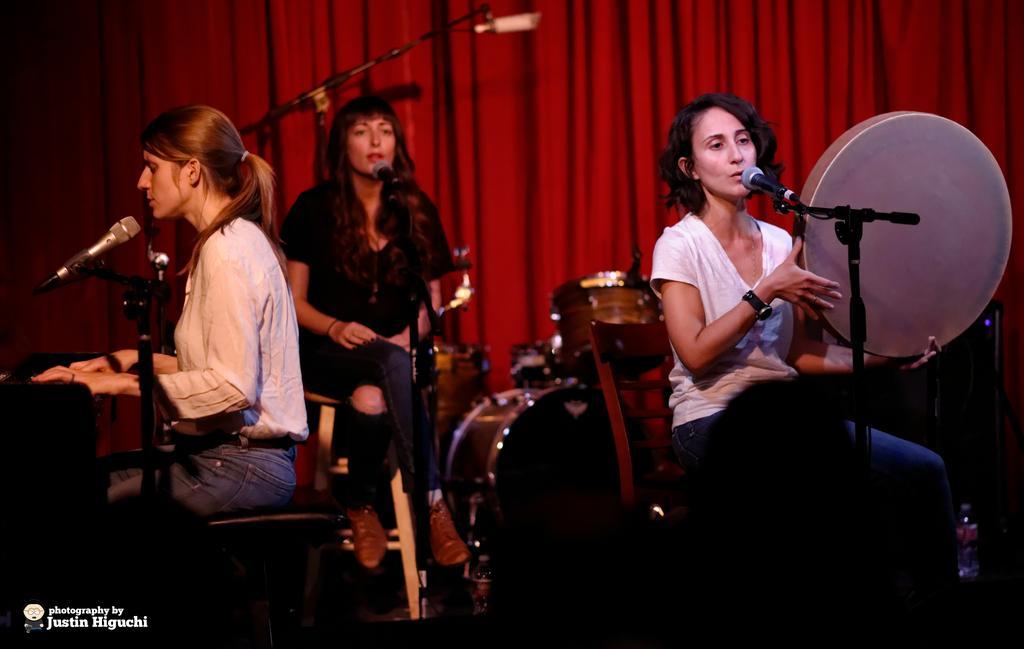How would you summarize this image in a sentence or two? This picture shows a few woman seated on the chairs and singing with the help of a microphones. We see a woman playing hand drum and we see another woman playing piano and we see a red color curtain and drums and water bottle on the floor and we see text at the bottom left corner. 